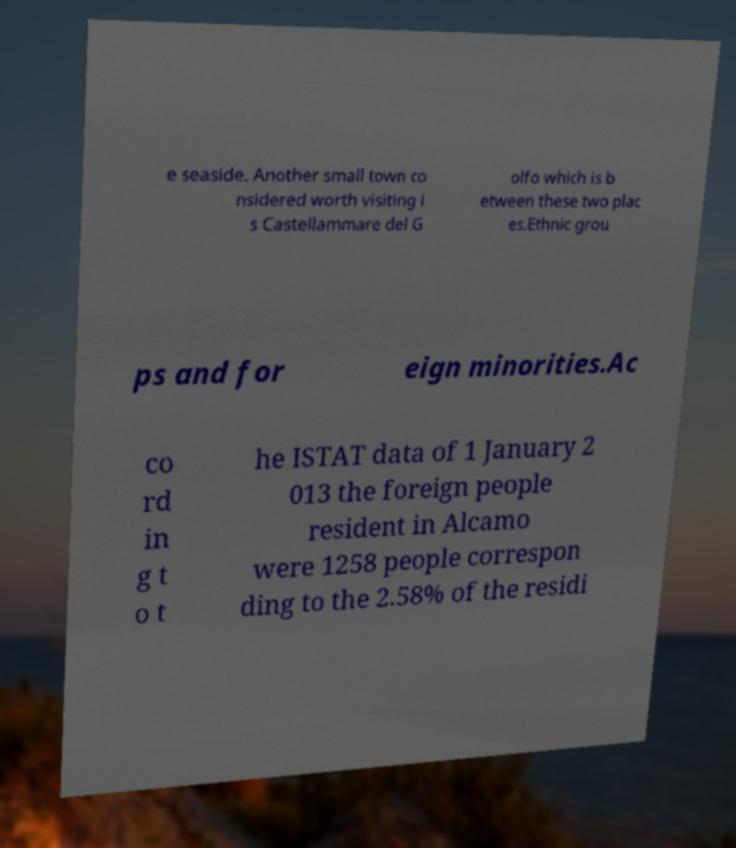Could you assist in decoding the text presented in this image and type it out clearly? e seaside. Another small town co nsidered worth visiting i s Castellammare del G olfo which is b etween these two plac es.Ethnic grou ps and for eign minorities.Ac co rd in g t o t he ISTAT data of 1 January 2 013 the foreign people resident in Alcamo were 1258 people correspon ding to the 2.58% of the residi 